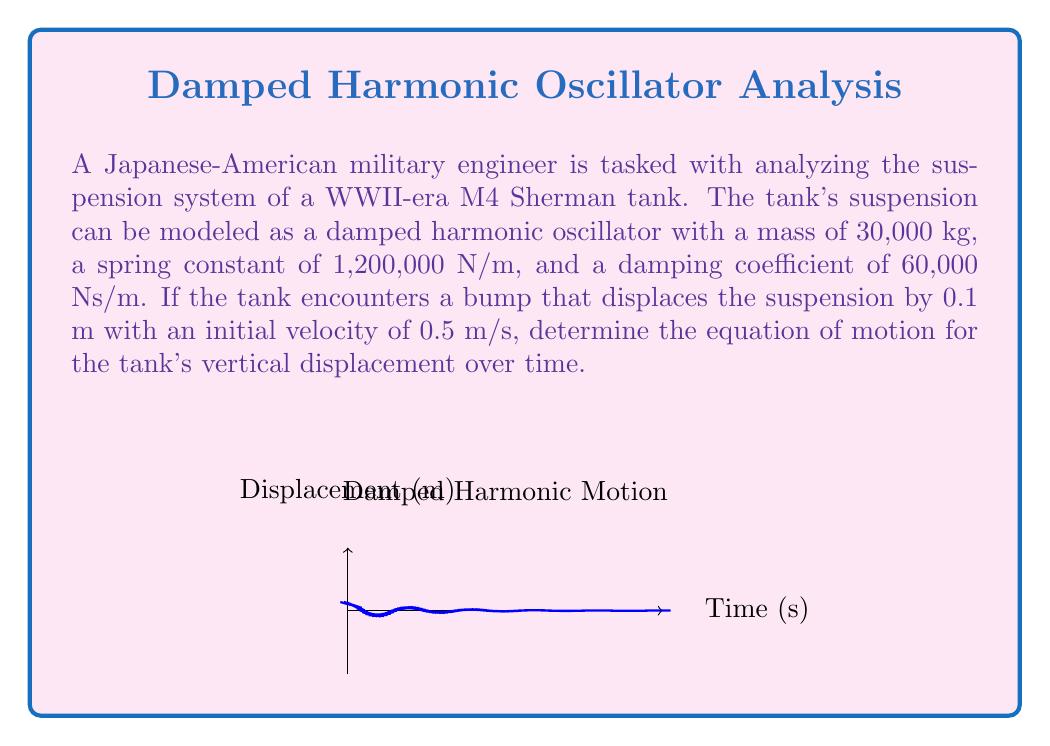Can you solve this math problem? To solve this problem, we'll use the general form of a damped harmonic oscillator:

$$m\frac{d^2x}{dt^2} + c\frac{dx}{dt} + kx = 0$$

Where:
$m$ = mass = 30,000 kg
$c$ = damping coefficient = 60,000 Ns/m
$k$ = spring constant = 1,200,000 N/m

Step 1: Calculate the natural frequency $\omega_0$:
$$\omega_0 = \sqrt{\frac{k}{m}} = \sqrt{\frac{1,200,000}{30,000}} = 6.32 \text{ rad/s}$$

Step 2: Calculate the damping ratio $\zeta$:
$$\zeta = \frac{c}{2\sqrt{km}} = \frac{60,000}{2\sqrt{1,200,000 \cdot 30,000}} = 0.158$$

Step 3: Since $0 < \zeta < 1$, this is an underdamped system. The general solution is:
$$x(t) = e^{-\zeta\omega_0 t}(A\cos(\omega_d t) + B\sin(\omega_d t))$$

Where $\omega_d = \omega_0\sqrt{1-\zeta^2} = 6.32\sqrt{1-0.158^2} = 6.19 \text{ rad/s}$

Step 4: Apply initial conditions:
$x(0) = 0.1 \text{ m}$
$\dot{x}(0) = 0.5 \text{ m/s}$

This gives us:
$A = 0.1$
$B = \frac{0.5 + 0.1\zeta\omega_0}{\omega_d} = 0.0911$

Step 5: Substitute these values into the general solution:

$$x(t) = e^{-1t}(0.1\cos(6.19t) + 0.0911\sin(6.19t))$$

Where we've rounded $\zeta\omega_0$ to 1 for simplicity.
Answer: $$x(t) = e^{-t}(0.1\cos(6.19t) + 0.0911\sin(6.19t))$$ 